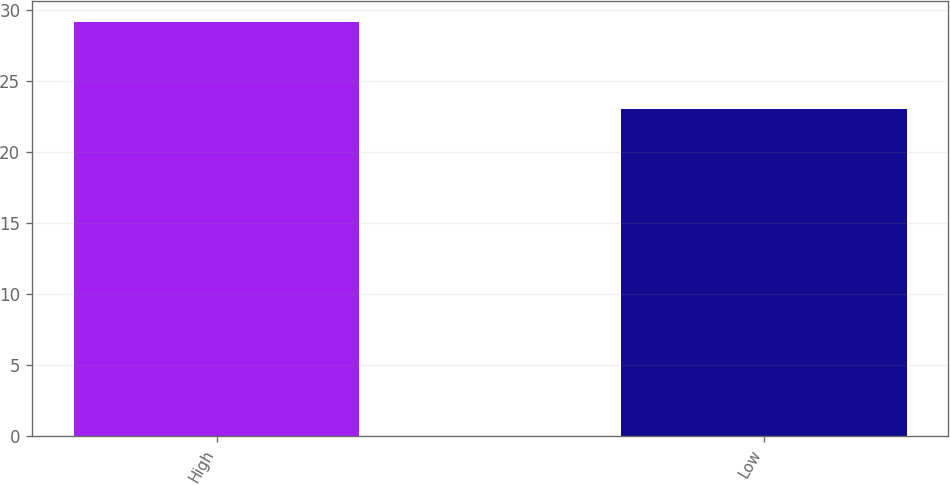Convert chart. <chart><loc_0><loc_0><loc_500><loc_500><bar_chart><fcel>High<fcel>Low<nl><fcel>29.17<fcel>23.01<nl></chart> 